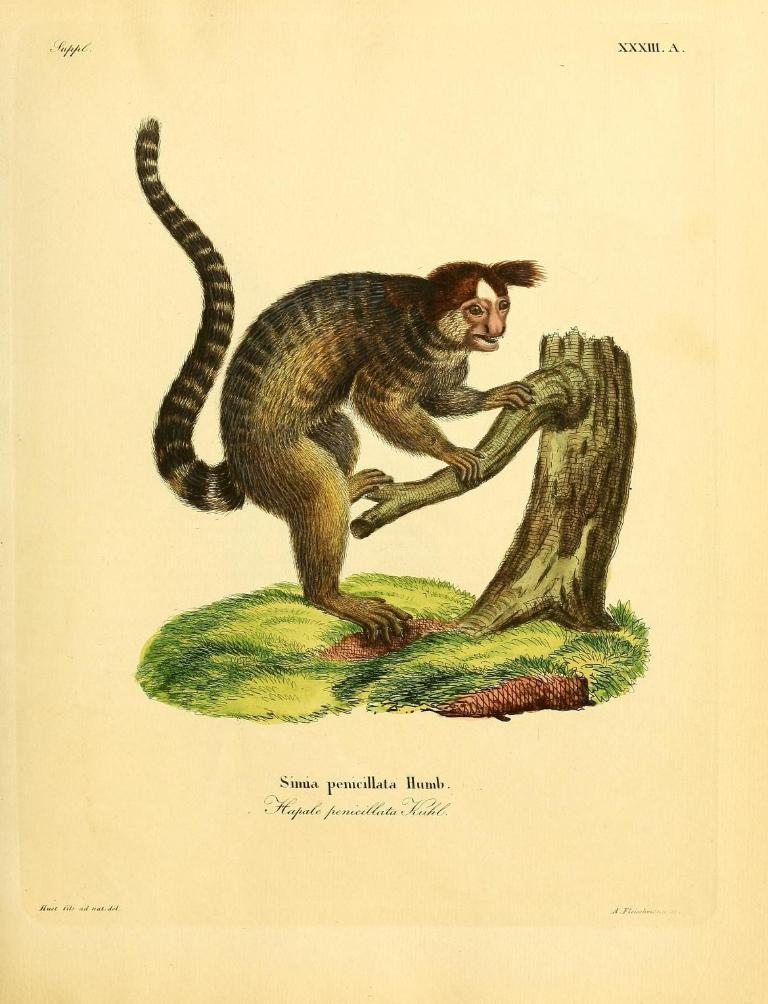What is depicted in the painting in the image? There is a painting of a monkey in the image. What is the monkey interacting with in the painting? The monkey is interacting with a tree branch in the painting. What else can be seen on the image besides the painting? There is text or writing on the image. How many flowers are present in the painting? There are no flowers depicted in the painting; it features a monkey interacting with a tree branch. What is the porter carrying in the image? There is no porter present in the image; it only contains a painting with text or writing. 